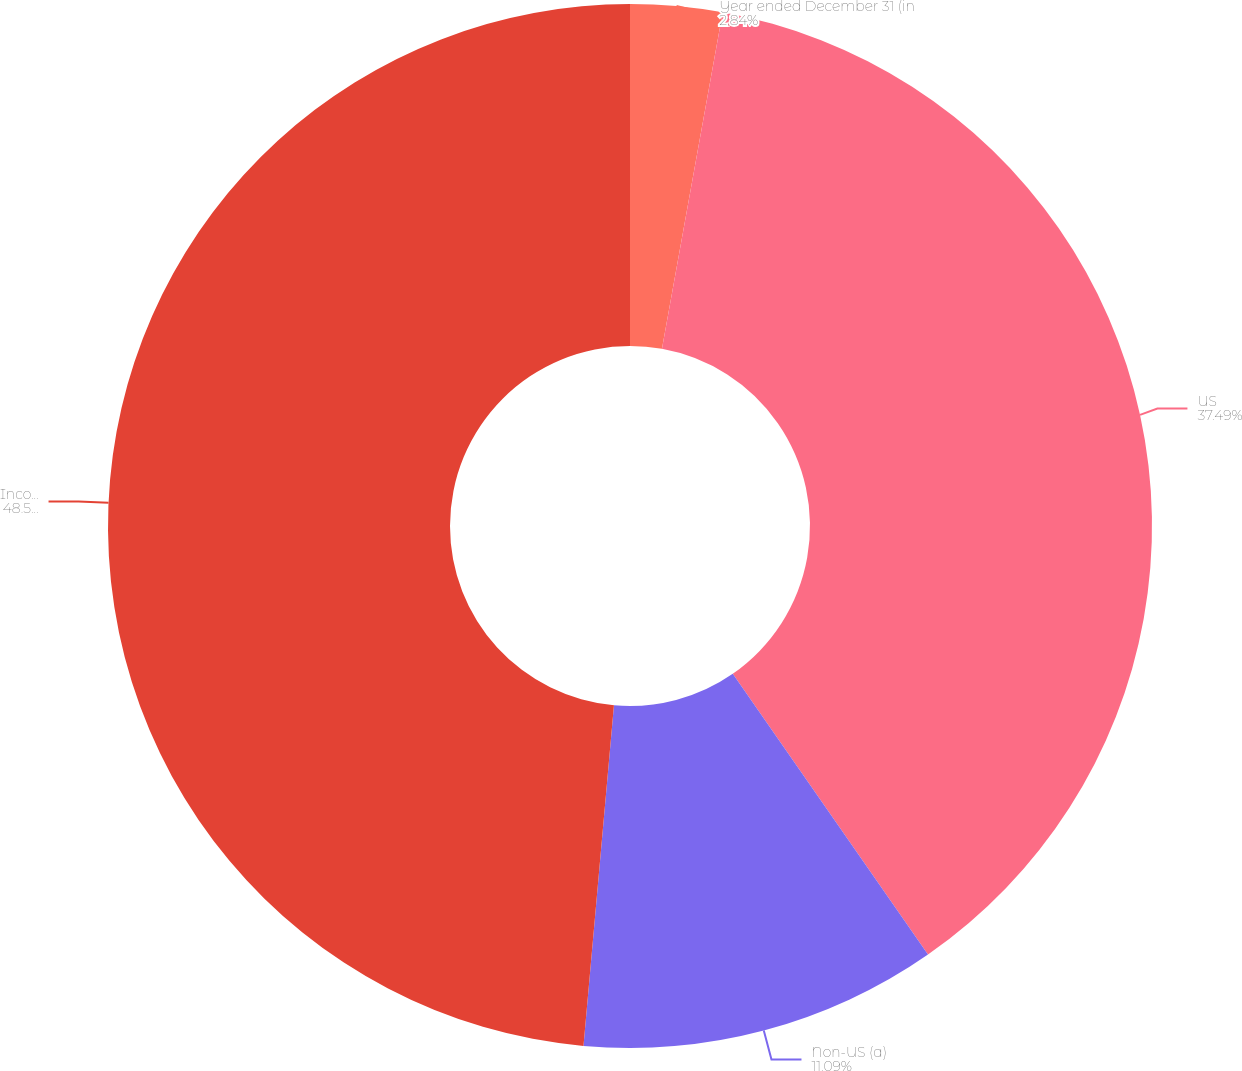<chart> <loc_0><loc_0><loc_500><loc_500><pie_chart><fcel>Year ended December 31 (in<fcel>US<fcel>Non-US (a)<fcel>Income before income tax<nl><fcel>2.84%<fcel>37.49%<fcel>11.09%<fcel>48.58%<nl></chart> 